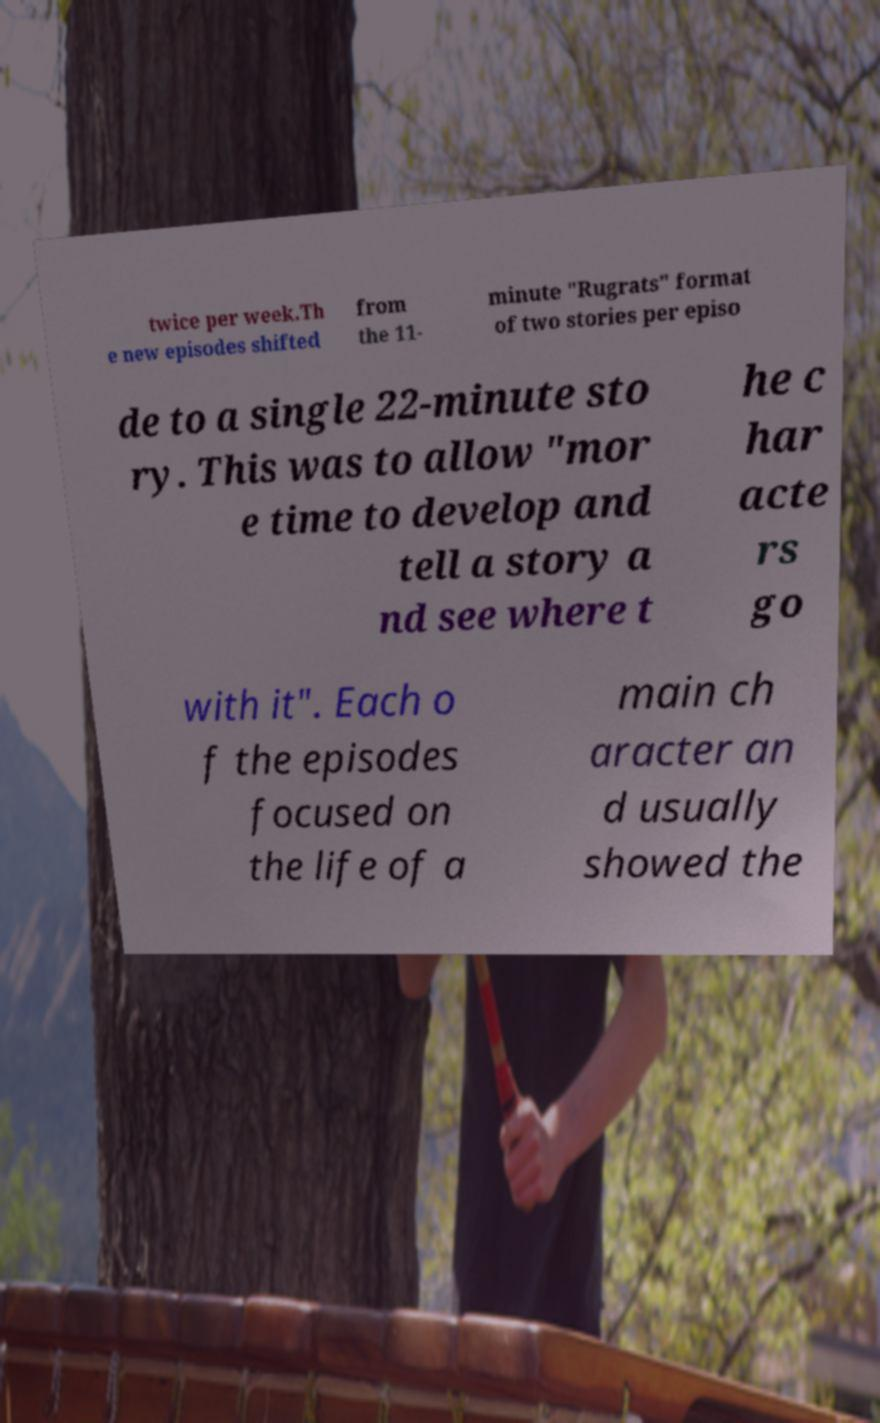I need the written content from this picture converted into text. Can you do that? twice per week.Th e new episodes shifted from the 11- minute "Rugrats" format of two stories per episo de to a single 22-minute sto ry. This was to allow "mor e time to develop and tell a story a nd see where t he c har acte rs go with it". Each o f the episodes focused on the life of a main ch aracter an d usually showed the 